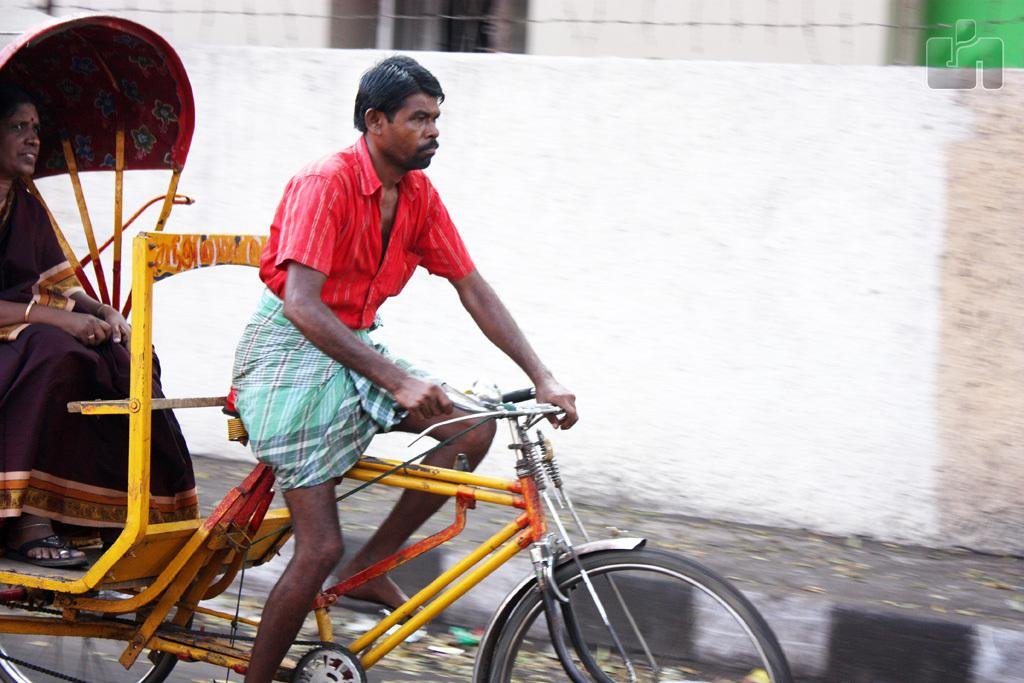What is the man in the image doing? The man is sitting and riding a rickshaw. Who is accompanying the man in the rickshaw? There is a woman sitting inside the rickshaw. What can be seen in the background of the image? There is a compound wall of a building in the background. What type of slope can be seen in the image? There is no slope present in the image; it features a man riding a rickshaw with a woman inside it and a compound wall in the background. What kind of iron object is visible in the image? There is no iron object visible in the image. 